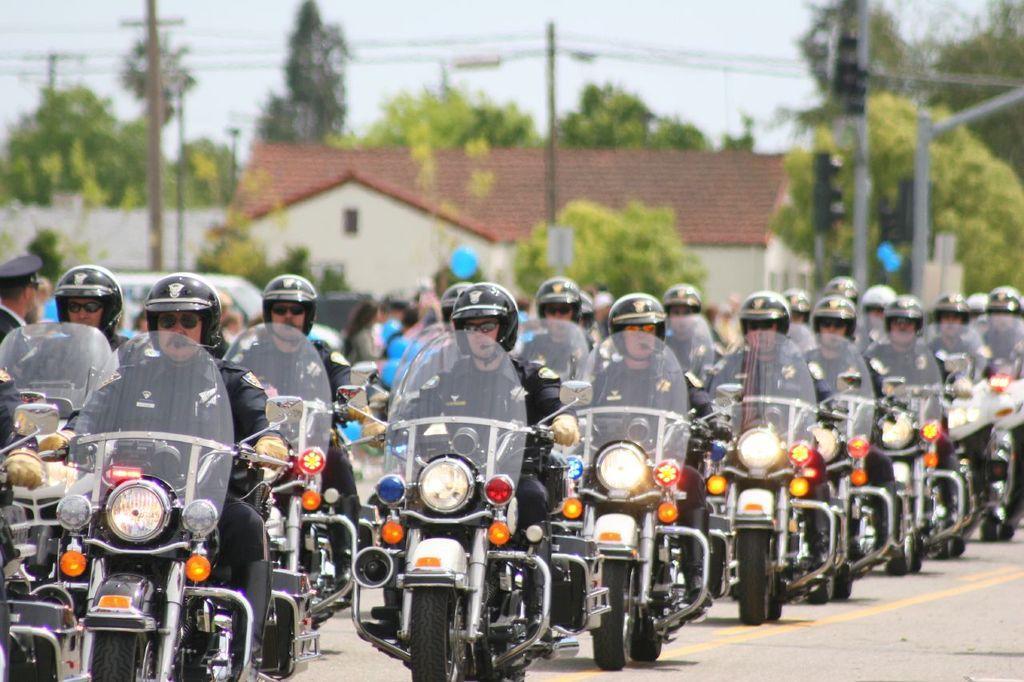Please provide a concise description of this image. In this image I can see group of people riding few bikes. In the background I can see few traffic signals, few electric poles and I can also see the building in white and brown color, trees in green color and the sky is in white color. 